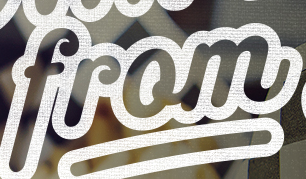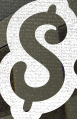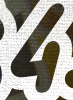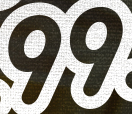What words can you see in these images in sequence, separated by a semicolon? from; $; 4; 99 